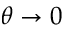<formula> <loc_0><loc_0><loc_500><loc_500>\theta \to 0</formula> 